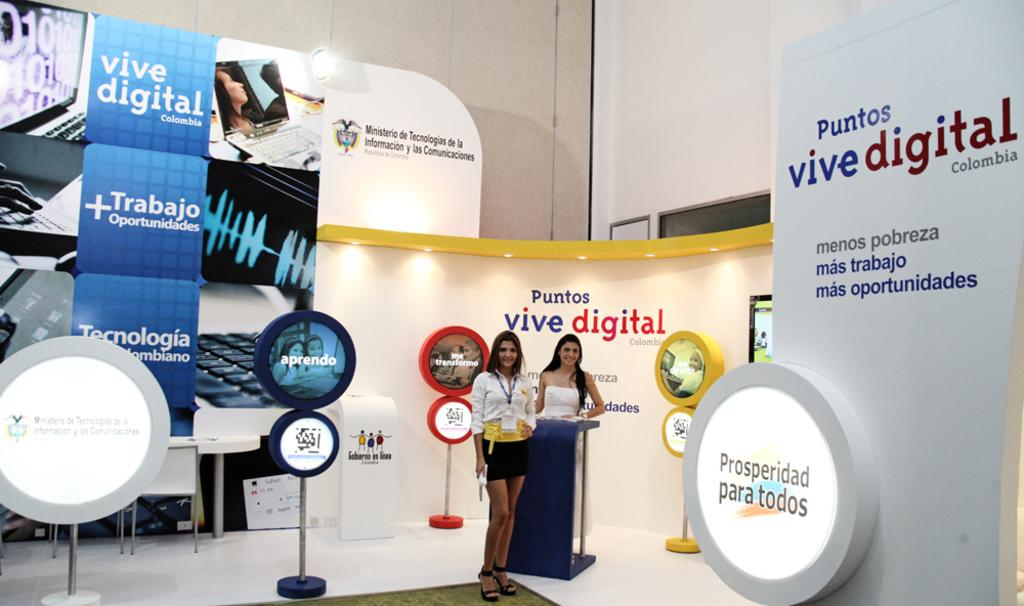How many women are in the image? There are two women in the image. What are the women doing in the image? The women are standing. What can be seen in the background of the image? There are hoardings visible in the image. What is the source of light in the image? There is a light in the image. What type of furniture is present in the image? There are chairs and a table in the image. What type of wound can be seen on the woman's arm in the image? There is no wound visible on any woman's arm in the image. What type of blood is present on the floor in the image? There is no blood present on the floor in the image. 